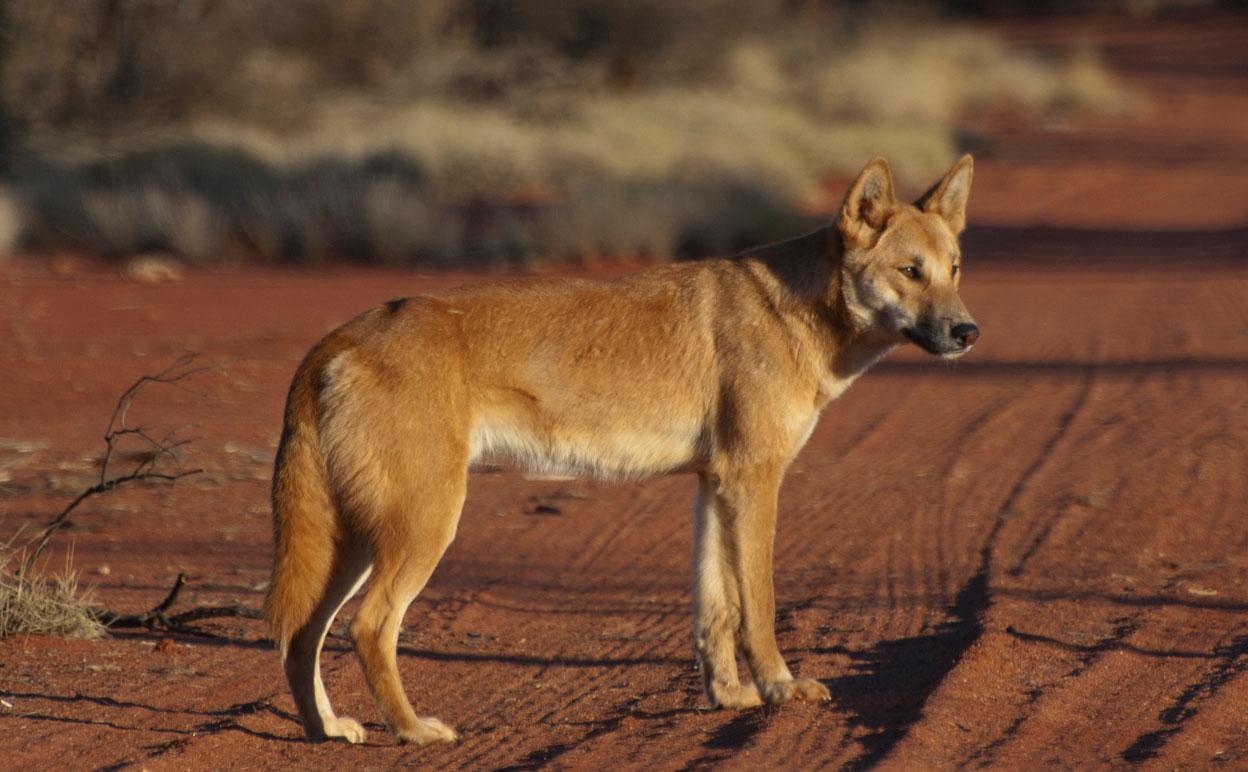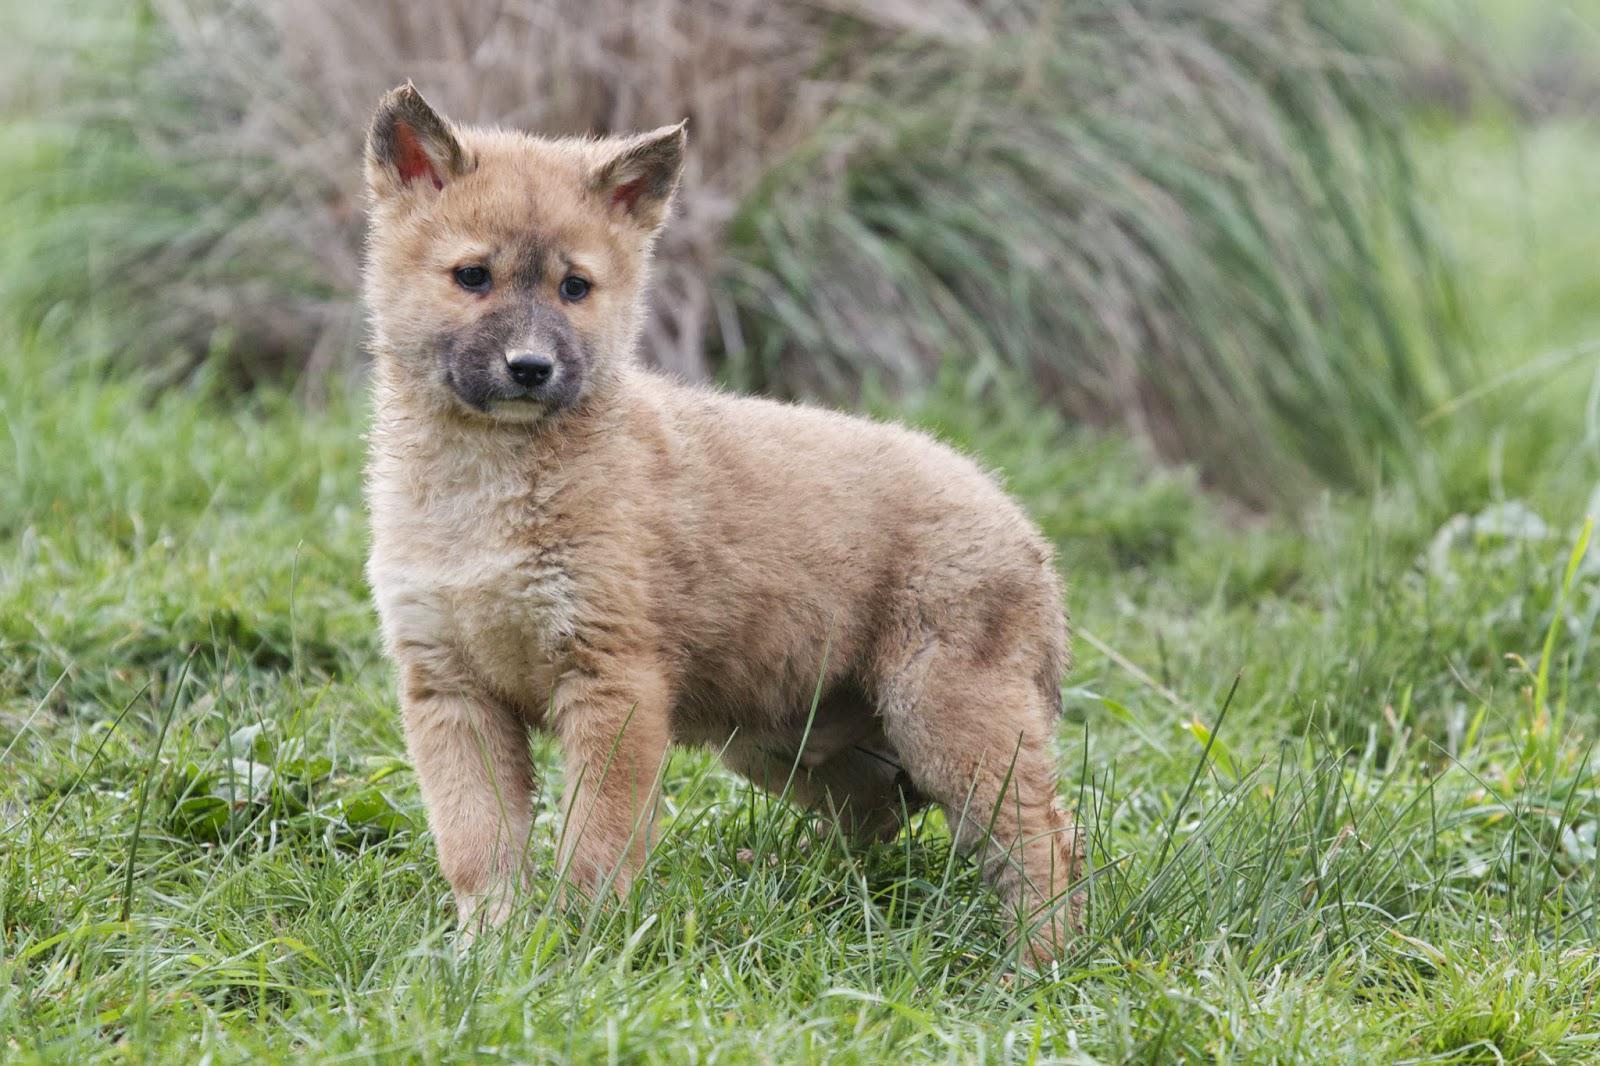The first image is the image on the left, the second image is the image on the right. Given the left and right images, does the statement "The right image contains two wild dogs." hold true? Answer yes or no. No. 